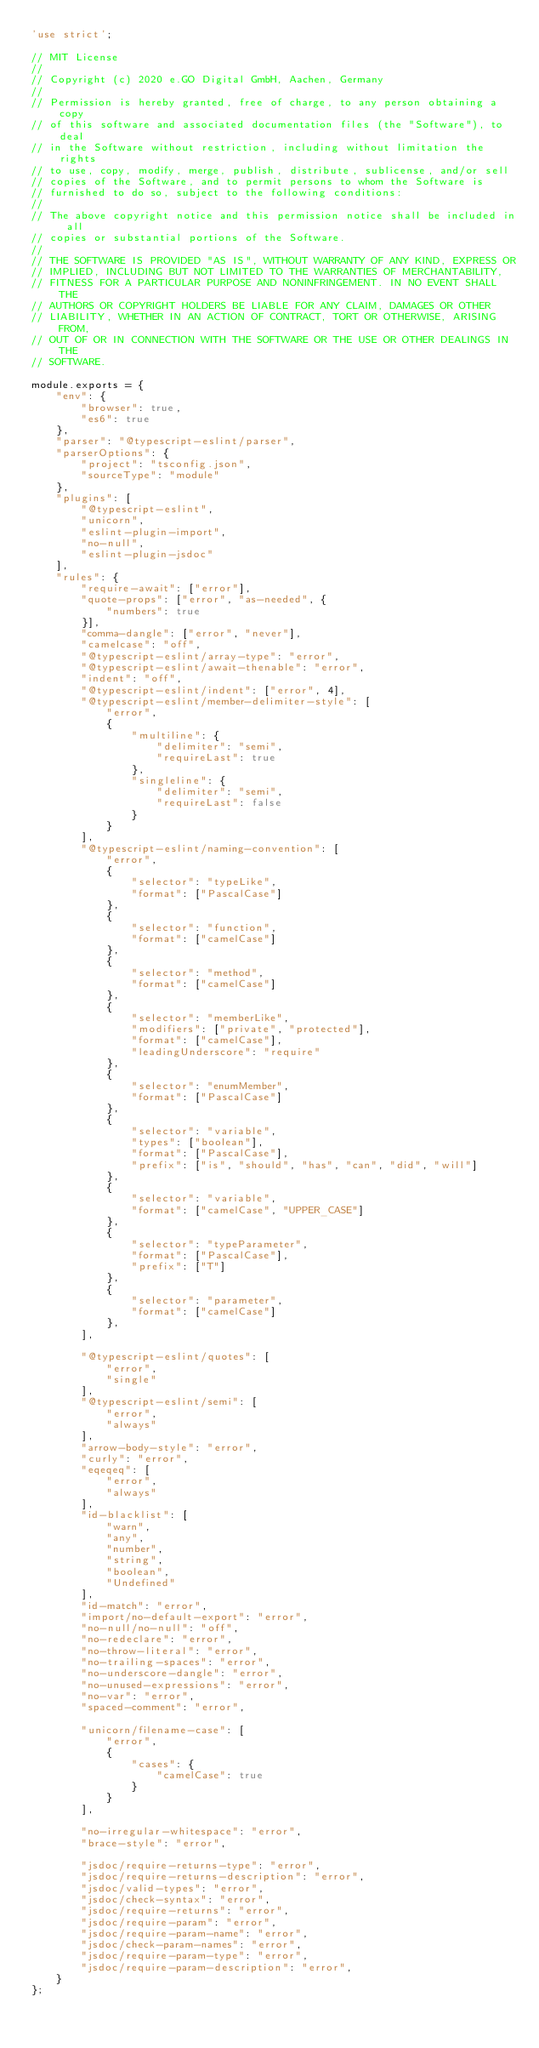<code> <loc_0><loc_0><loc_500><loc_500><_JavaScript_>'use strict';

// MIT License
// 
// Copyright (c) 2020 e.GO Digital GmbH, Aachen, Germany
// 
// Permission is hereby granted, free of charge, to any person obtaining a copy
// of this software and associated documentation files (the "Software"), to deal
// in the Software without restriction, including without limitation the rights
// to use, copy, modify, merge, publish, distribute, sublicense, and/or sell
// copies of the Software, and to permit persons to whom the Software is
// furnished to do so, subject to the following conditions:
// 
// The above copyright notice and this permission notice shall be included in all
// copies or substantial portions of the Software.
// 
// THE SOFTWARE IS PROVIDED "AS IS", WITHOUT WARRANTY OF ANY KIND, EXPRESS OR
// IMPLIED, INCLUDING BUT NOT LIMITED TO THE WARRANTIES OF MERCHANTABILITY,
// FITNESS FOR A PARTICULAR PURPOSE AND NONINFRINGEMENT. IN NO EVENT SHALL THE
// AUTHORS OR COPYRIGHT HOLDERS BE LIABLE FOR ANY CLAIM, DAMAGES OR OTHER
// LIABILITY, WHETHER IN AN ACTION OF CONTRACT, TORT OR OTHERWISE, ARISING FROM,
// OUT OF OR IN CONNECTION WITH THE SOFTWARE OR THE USE OR OTHER DEALINGS IN THE
// SOFTWARE.

module.exports = {
    "env": {
        "browser": true,
        "es6": true
    },
    "parser": "@typescript-eslint/parser",
    "parserOptions": {
        "project": "tsconfig.json",
        "sourceType": "module"
    },
    "plugins": [
        "@typescript-eslint",
        "unicorn",
        "eslint-plugin-import",
        "no-null",
        "eslint-plugin-jsdoc"
    ],
    "rules": {
        "require-await": ["error"],
        "quote-props": ["error", "as-needed", {
            "numbers": true
        }],
        "comma-dangle": ["error", "never"],
        "camelcase": "off",
        "@typescript-eslint/array-type": "error",
        "@typescript-eslint/await-thenable": "error",
        "indent": "off",
        "@typescript-eslint/indent": ["error", 4],
        "@typescript-eslint/member-delimiter-style": [
            "error",
            {
                "multiline": {
                    "delimiter": "semi",
                    "requireLast": true
                },
                "singleline": {
                    "delimiter": "semi",
                    "requireLast": false
                }
            }
        ],
        "@typescript-eslint/naming-convention": [
            "error",
            {
                "selector": "typeLike",
                "format": ["PascalCase"]
            },
            {
                "selector": "function",
                "format": ["camelCase"]
            },
            {
                "selector": "method",
                "format": ["camelCase"]
            },
            {
                "selector": "memberLike",
                "modifiers": ["private", "protected"],
                "format": ["camelCase"],
                "leadingUnderscore": "require"
            },
            {
                "selector": "enumMember",
                "format": ["PascalCase"]
            },
            {
                "selector": "variable",
                "types": ["boolean"],
                "format": ["PascalCase"],
                "prefix": ["is", "should", "has", "can", "did", "will"]
            },
            {
                "selector": "variable",
                "format": ["camelCase", "UPPER_CASE"]
            },
            {
                "selector": "typeParameter",
                "format": ["PascalCase"],
                "prefix": ["T"]
            },
            {
                "selector": "parameter",
                "format": ["camelCase"]
            },
        ],

        "@typescript-eslint/quotes": [
            "error",
            "single"
        ],
        "@typescript-eslint/semi": [
            "error",
            "always"
        ],
        "arrow-body-style": "error",
        "curly": "error",
        "eqeqeq": [
            "error",
            "always"
        ],
        "id-blacklist": [
            "warn",
            "any",
            "number",
            "string",
            "boolean",
            "Undefined"
        ],
        "id-match": "error",
        "import/no-default-export": "error",
        "no-null/no-null": "off",
        "no-redeclare": "error",
        "no-throw-literal": "error",
        "no-trailing-spaces": "error",
        "no-underscore-dangle": "error",
        "no-unused-expressions": "error",
        "no-var": "error",
        "spaced-comment": "error",

        "unicorn/filename-case": [
            "error",
            {
                "cases": {
                    "camelCase": true
                }
            }
        ],

        "no-irregular-whitespace": "error",
        "brace-style": "error",

        "jsdoc/require-returns-type": "error",
        "jsdoc/require-returns-description": "error",
        "jsdoc/valid-types": "error",
        "jsdoc/check-syntax": "error",
        "jsdoc/require-returns": "error",
        "jsdoc/require-param": "error",
        "jsdoc/require-param-name": "error",
        "jsdoc/check-param-names": "error",
        "jsdoc/require-param-type": "error",
        "jsdoc/require-param-description": "error",
    }
};
</code> 